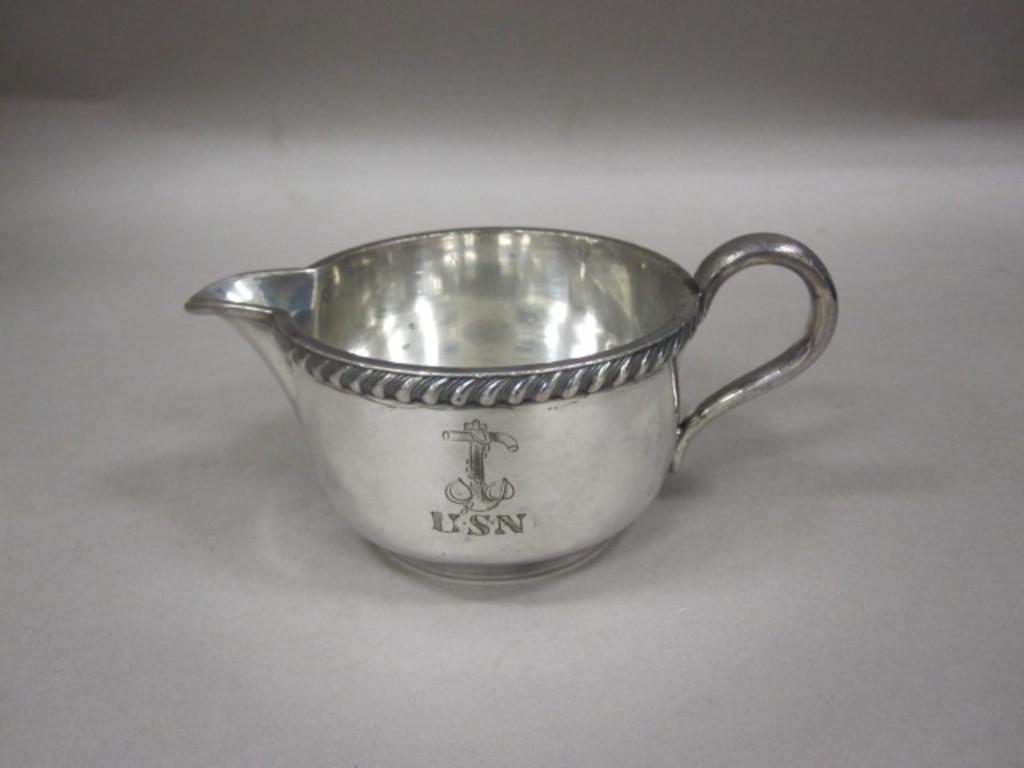Could you give a brief overview of what you see in this image? In this image I can see a metal cup on a surface. 